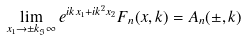Convert formula to latex. <formula><loc_0><loc_0><loc_500><loc_500>\lim _ { x _ { 1 } \rightarrow \pm k _ { \Im } \infty } e ^ { i k x _ { 1 } + i k ^ { 2 } x _ { 2 } } F _ { n } ( x , k ) = A _ { n } ( \pm , k )</formula> 